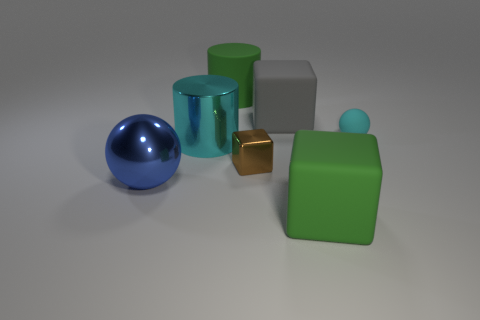Add 2 large cubes. How many objects exist? 9 Subtract all cylinders. How many objects are left? 5 Subtract all large cyan cubes. Subtract all brown blocks. How many objects are left? 6 Add 7 big blue things. How many big blue things are left? 8 Add 6 big cyan metal things. How many big cyan metal things exist? 7 Subtract 1 cyan balls. How many objects are left? 6 